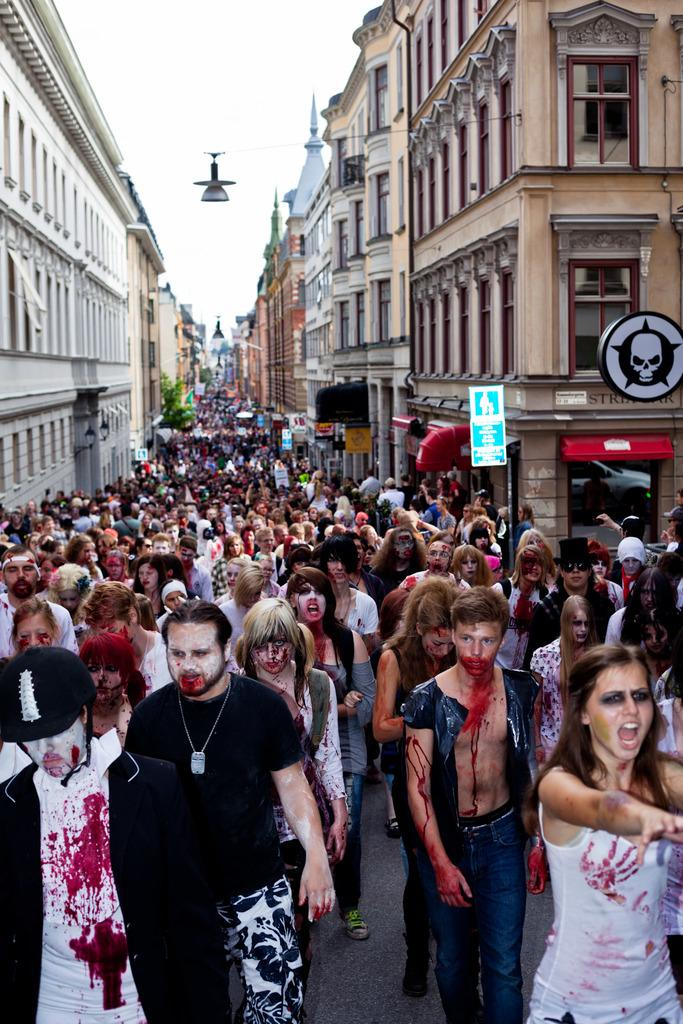What is the main subject of the image? The main subject of the image is a crowd. Where is the crowd located in the image? The crowd is in the middle of the image. What can be seen in the background of the image? There are buildings in the background of the image. What is visible at the top of the image? The sky is visible at the top of the image. What type of corn can be seen growing in the image? There is no corn present in the image. How does the cream affect the appearance of the crowd in the image? There is no cream present in the image, so it cannot affect the appearance of the crowd. 